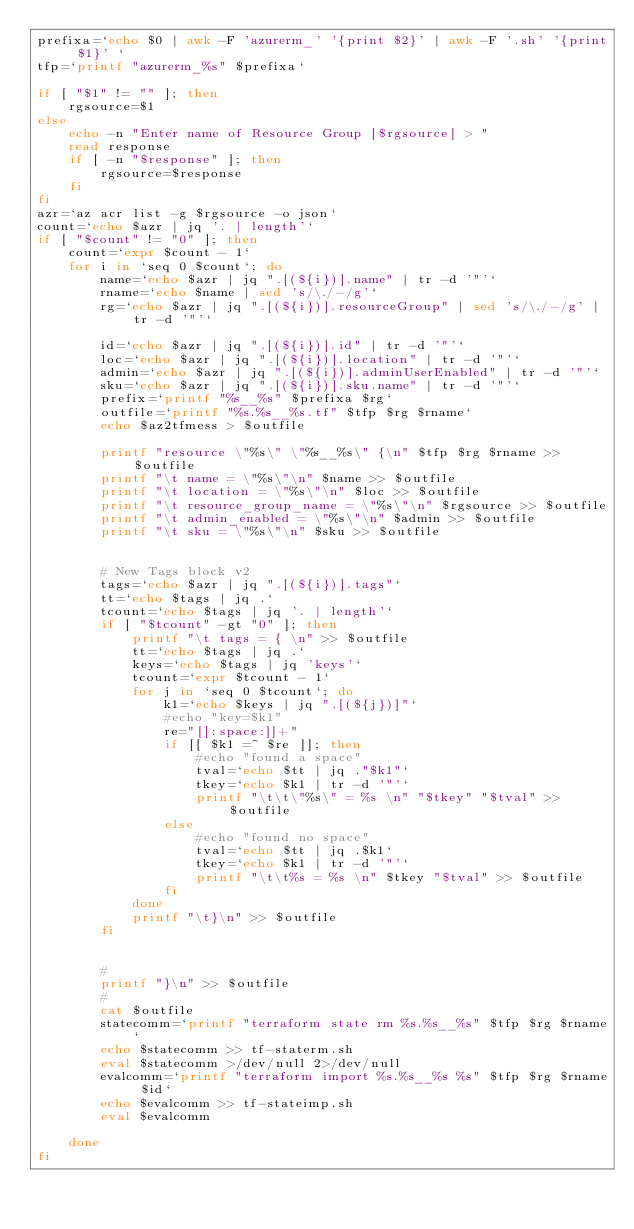<code> <loc_0><loc_0><loc_500><loc_500><_Bash_>prefixa=`echo $0 | awk -F 'azurerm_' '{print $2}' | awk -F '.sh' '{print $1}' `
tfp=`printf "azurerm_%s" $prefixa`

if [ "$1" != "" ]; then
    rgsource=$1
else
    echo -n "Enter name of Resource Group [$rgsource] > "
    read response
    if [ -n "$response" ]; then
        rgsource=$response
    fi
fi
azr=`az acr list -g $rgsource -o json`
count=`echo $azr | jq '. | length'`
if [ "$count" != "0" ]; then
    count=`expr $count - 1`
    for i in `seq 0 $count`; do
        name=`echo $azr | jq ".[(${i})].name" | tr -d '"'`
        rname=`echo $name | sed 's/\./-/g'`
        rg=`echo $azr | jq ".[(${i})].resourceGroup" | sed 's/\./-/g' | tr -d '"'`

        id=`echo $azr | jq ".[(${i})].id" | tr -d '"'`
        loc=`echo $azr | jq ".[(${i})].location" | tr -d '"'`
        admin=`echo $azr | jq ".[(${i})].adminUserEnabled" | tr -d '"'`
        sku=`echo $azr | jq ".[(${i})].sku.name" | tr -d '"'`
        prefix=`printf "%s__%s" $prefixa $rg`
        outfile=`printf "%s.%s__%s.tf" $tfp $rg $rname`
        echo $az2tfmess > $outfile
        
        printf "resource \"%s\" \"%s__%s\" {\n" $tfp $rg $rname >> $outfile
        printf "\t name = \"%s\"\n" $name >> $outfile
        printf "\t location = \"%s\"\n" $loc >> $outfile
        printf "\t resource_group_name = \"%s\"\n" $rgsource >> $outfile
        printf "\t admin_enabled = \"%s\"\n" $admin >> $outfile
        printf "\t sku = \"%s\"\n" $sku >> $outfile
        
        
        # New Tags block v2
        tags=`echo $azr | jq ".[(${i})].tags"`
        tt=`echo $tags | jq .`
        tcount=`echo $tags | jq '. | length'`
        if [ "$tcount" -gt "0" ]; then
            printf "\t tags = { \n" >> $outfile
            tt=`echo $tags | jq .`
            keys=`echo $tags | jq 'keys'`
            tcount=`expr $tcount - 1`
            for j in `seq 0 $tcount`; do
                k1=`echo $keys | jq ".[(${j})]"`
                #echo "key=$k1"
                re="[[:space:]]+"
                if [[ $k1 =~ $re ]]; then
                    #echo "found a space"
                    tval=`echo $tt | jq ."$k1"`
                    tkey=`echo $k1 | tr -d '"'`
                    printf "\t\t\"%s\" = %s \n" "$tkey" "$tval" >> $outfile
                else
                    #echo "found no space"
                    tval=`echo $tt | jq .$k1`
                    tkey=`echo $k1 | tr -d '"'`
                    printf "\t\t%s = %s \n" $tkey "$tval" >> $outfile
                fi
            done
            printf "\t}\n" >> $outfile
        fi
               
        
        #
        printf "}\n" >> $outfile
        #
        cat $outfile
        statecomm=`printf "terraform state rm %s.%s__%s" $tfp $rg $rname`
        echo $statecomm >> tf-staterm.sh
        eval $statecomm >/dev/null 2>/dev/null
        evalcomm=`printf "terraform import %s.%s__%s %s" $tfp $rg $rname $id`
        echo $evalcomm >> tf-stateimp.sh
        eval $evalcomm
        
    done
fi
</code> 